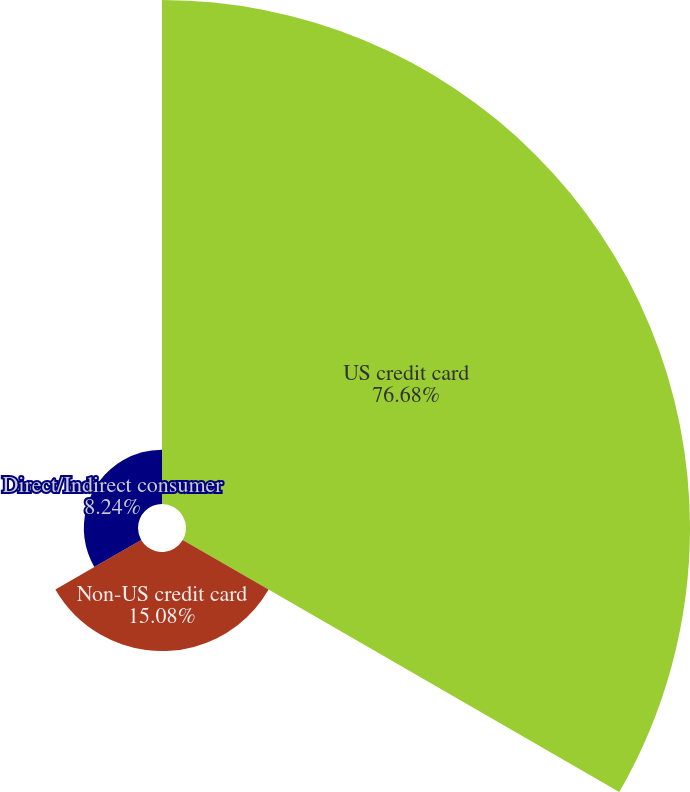Convert chart to OTSL. <chart><loc_0><loc_0><loc_500><loc_500><pie_chart><fcel>US credit card<fcel>Non-US credit card<fcel>Direct/Indirect consumer<nl><fcel>76.68%<fcel>15.08%<fcel>8.24%<nl></chart> 